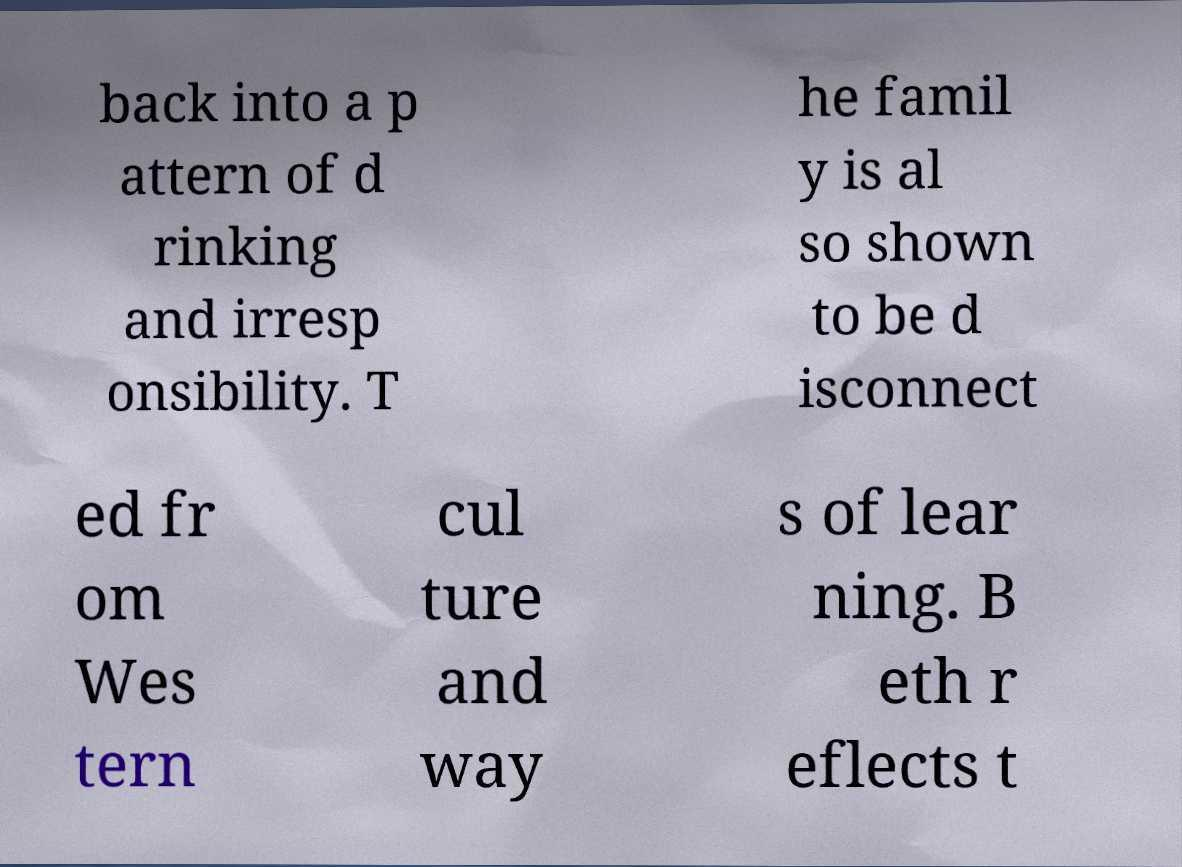Can you accurately transcribe the text from the provided image for me? back into a p attern of d rinking and irresp onsibility. T he famil y is al so shown to be d isconnect ed fr om Wes tern cul ture and way s of lear ning. B eth r eflects t 